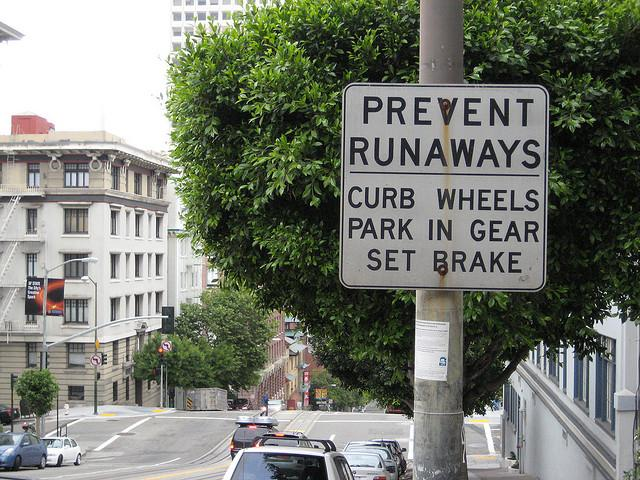What type vehicle does this sign refer to?

Choices:
A) large truck
B) bike
C) roller blade
D) mini bike large truck 